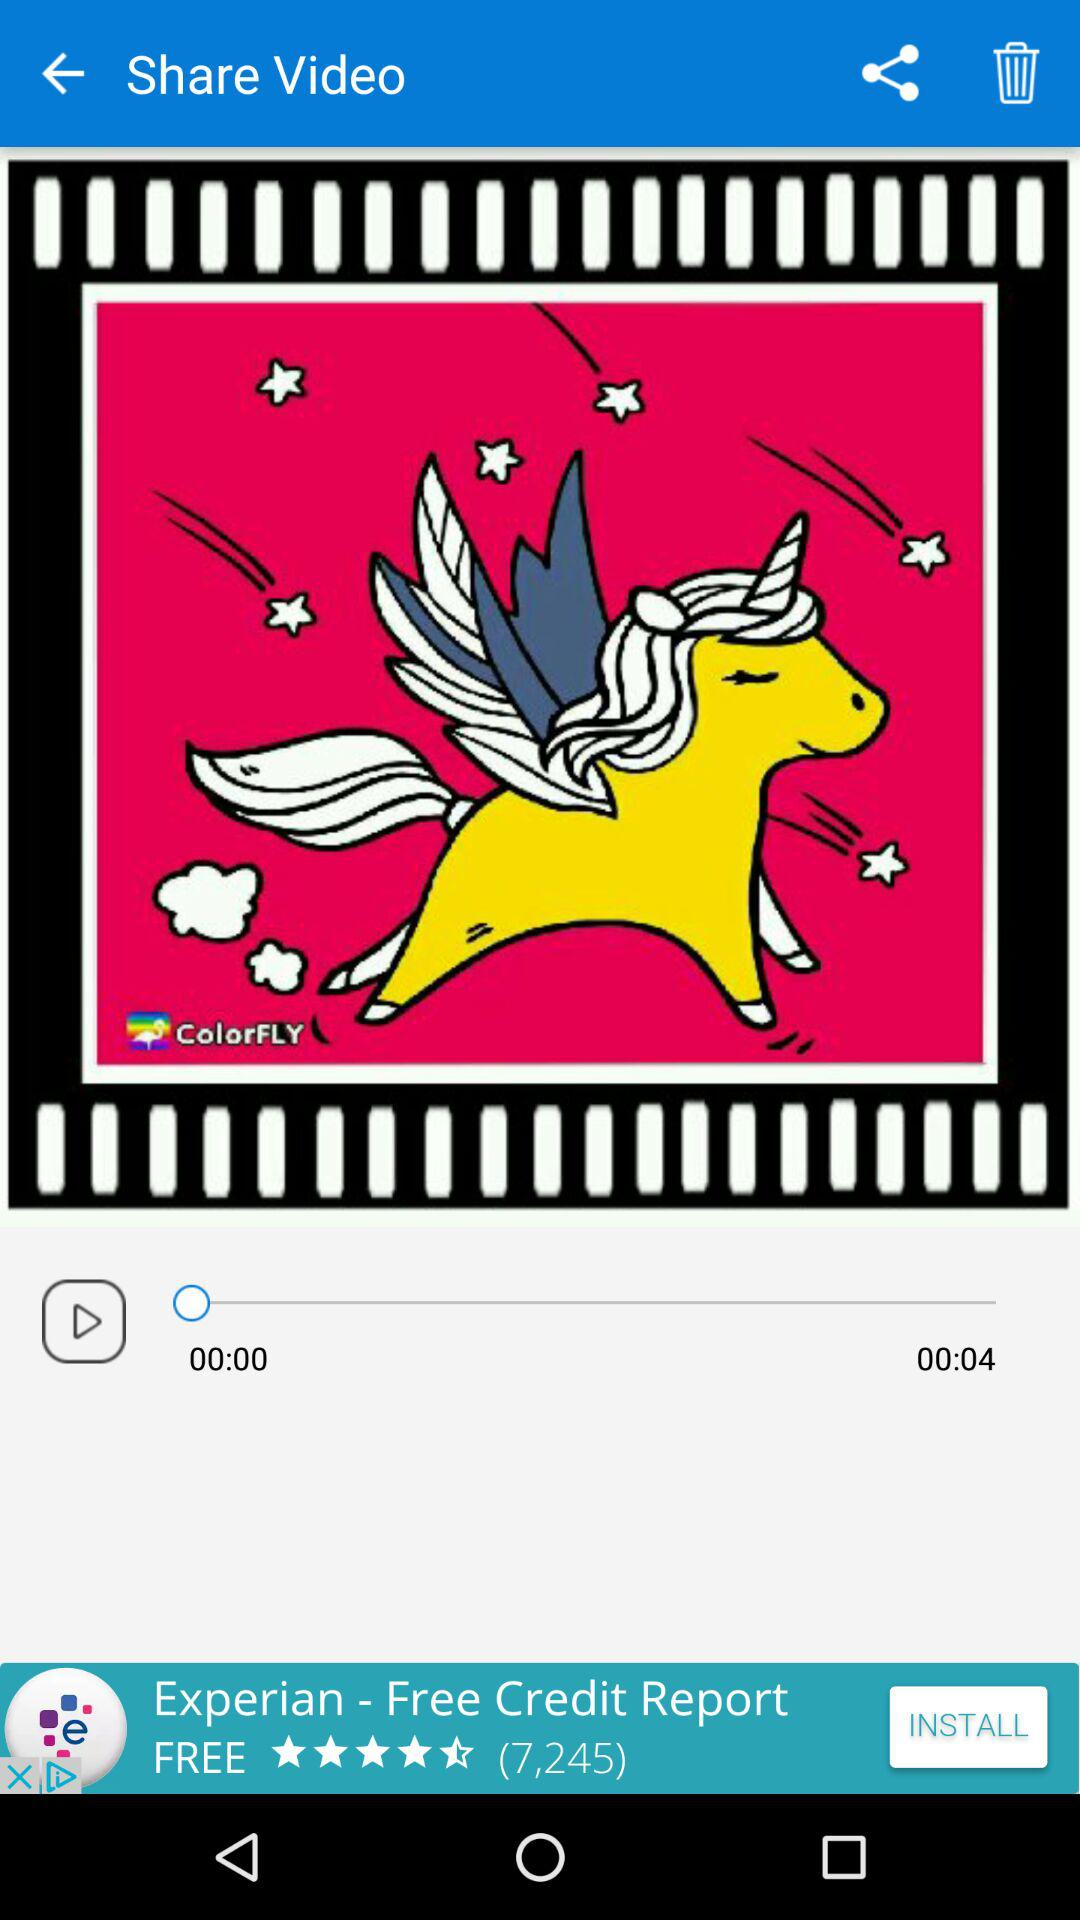How many more seconds are in the video than the time elapsed?
Answer the question using a single word or phrase. 4 